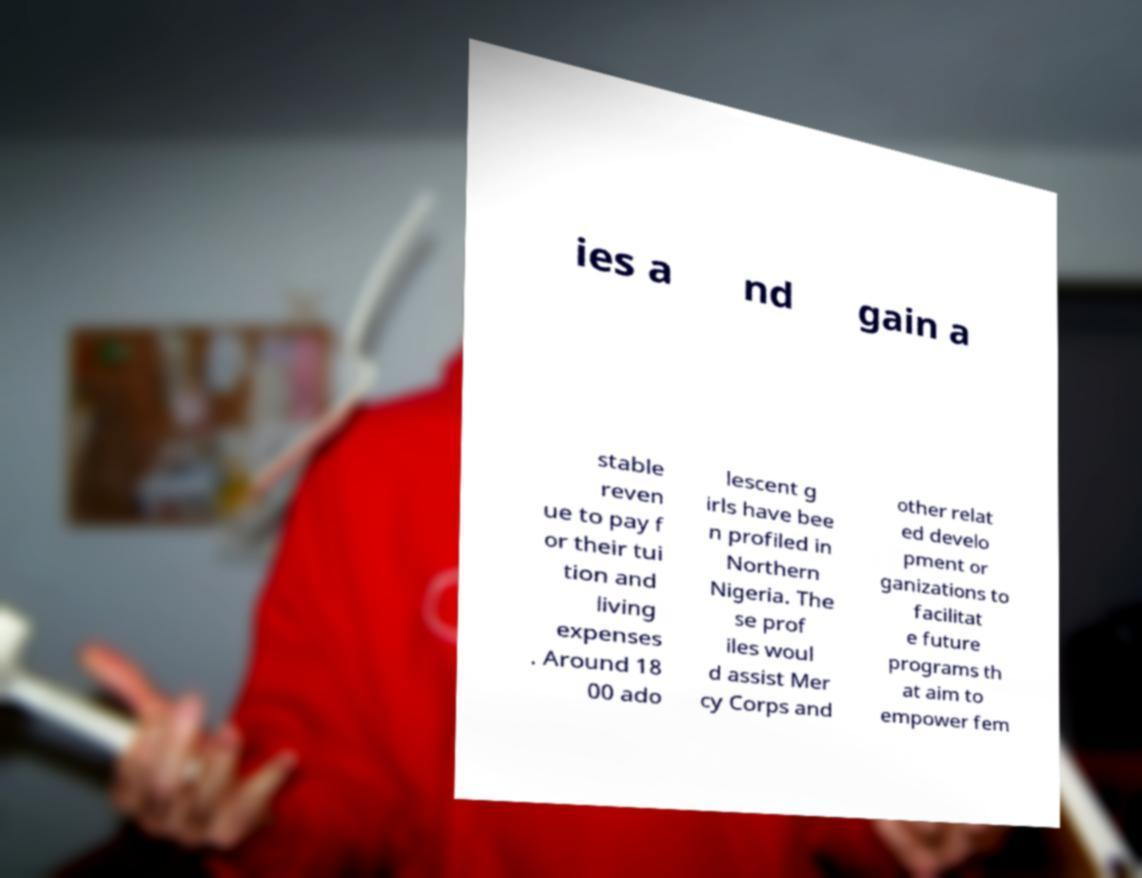What messages or text are displayed in this image? I need them in a readable, typed format. ies a nd gain a stable reven ue to pay f or their tui tion and living expenses . Around 18 00 ado lescent g irls have bee n profiled in Northern Nigeria. The se prof iles woul d assist Mer cy Corps and other relat ed develo pment or ganizations to facilitat e future programs th at aim to empower fem 